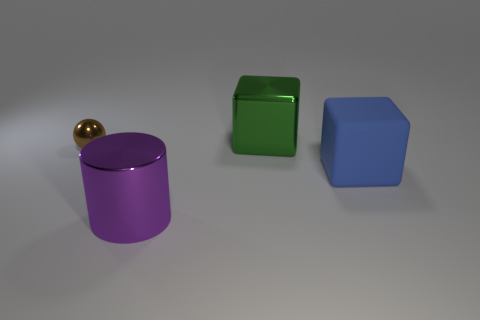What materials do the objects in the image appear to be made of? The objects in the image seem to have metallic surfaces. The cylinder has a glossy purple finish suggestive of a metallic paint, while the cube and the block also have reflective surfaces that are indicative of metal materials. The sphere, with its golden color and shiny appearance, could be interpreted as being made of polished brass or a gold-like alloy. 